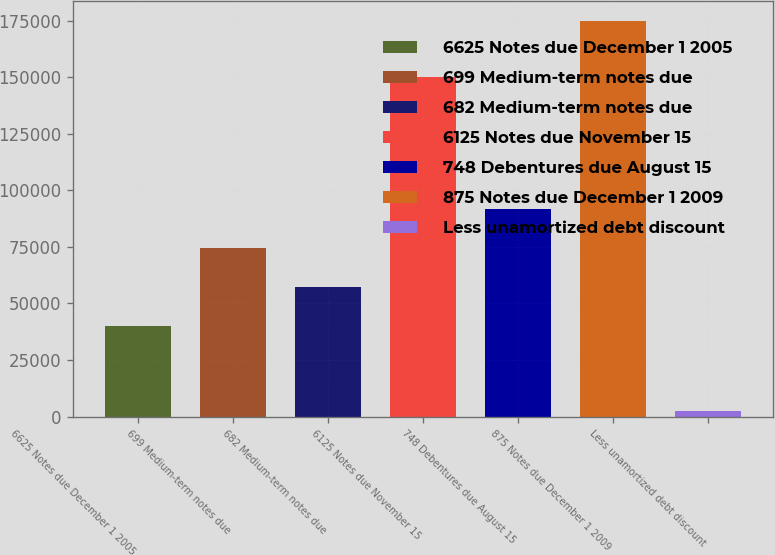Convert chart. <chart><loc_0><loc_0><loc_500><loc_500><bar_chart><fcel>6625 Notes due December 1 2005<fcel>699 Medium-term notes due<fcel>682 Medium-term notes due<fcel>6125 Notes due November 15<fcel>748 Debentures due August 15<fcel>875 Notes due December 1 2009<fcel>Less unamortized debt discount<nl><fcel>40000<fcel>74524.2<fcel>57262.1<fcel>150000<fcel>91786.3<fcel>175000<fcel>2379<nl></chart> 